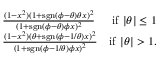Convert formula to latex. <formula><loc_0><loc_0><loc_500><loc_500>\begin{array} { r l r } & { \frac { ( 1 - x ^ { 2 } ) ( 1 + s g n ( \phi - \theta ) \theta x ) ^ { 2 } } { ( 1 + s g n ( \phi - \theta ) \phi x ) ^ { 2 } } } & { i f | \theta | \leq 1 } \\ & { \frac { ( 1 - x ^ { 2 } ) ( \theta + s g n ( \phi - 1 / \theta ) x ) ^ { 2 } } { ( 1 + s g n ( \phi - 1 / \theta ) \phi x ) ^ { 2 } } } & { i f | \theta | > 1 . } \end{array}</formula> 